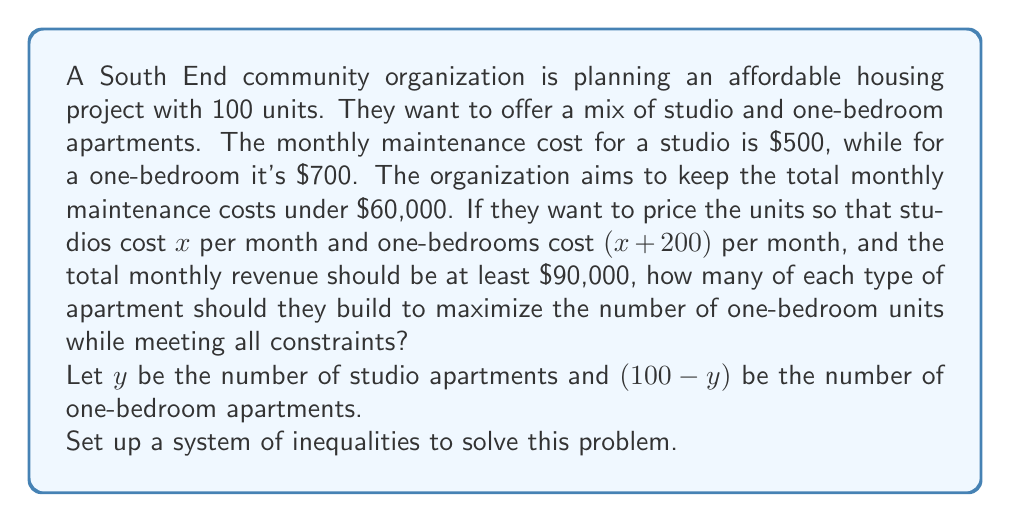Could you help me with this problem? Let's approach this step-by-step:

1) First, let's set up the maintenance cost inequality:
   $500y + 700(100-y) \leq 60000$

2) Now, let's set up the revenue inequality:
   $xy + (x+200)(100-y) \geq 90000$

3) We also know that $y$ must be between 0 and 100:
   $0 \leq y \leq 100$

4) Simplifying the maintenance cost inequality:
   $500y + 70000 - 700y \leq 60000$
   $-200y \leq -10000$
   $y \geq 50$

5) Simplifying the revenue inequality:
   $xy + 100x + 20000 - xy \geq 90000$
   $100x \geq 70000$
   $x \geq 700$

6) Since we want to maximize the number of one-bedroom apartments, we want to minimize $y$ while still meeting all constraints. The minimum value for $y$ that satisfies all inequalities is 50.

7) Substituting $y = 50$ into the revenue inequality:
   $700 \cdot 50 + 900 \cdot 50 \geq 90000$
   $35000 + 45000 = 80000 \geq 90000$

   This doesn't meet the revenue requirement, so we need to increase $x$.

8) Solving for $x$:
   $50x + (50)(x+200) = 90000$
   $100x + 10000 = 90000$
   $100x = 80000$
   $x = 800$

9) Verifying:
   Revenue: $800 \cdot 50 + 1000 \cdot 50 = 90000$
   Maintenance: $500 \cdot 50 + 700 \cdot 50 = 60000$

Therefore, the optimal solution is 50 studio apartments at $800 per month and 50 one-bedroom apartments at $1000 per month.
Answer: The community organization should build 50 studio apartments and 50 one-bedroom apartments, pricing the studios at $800 per month and the one-bedrooms at $1000 per month. 